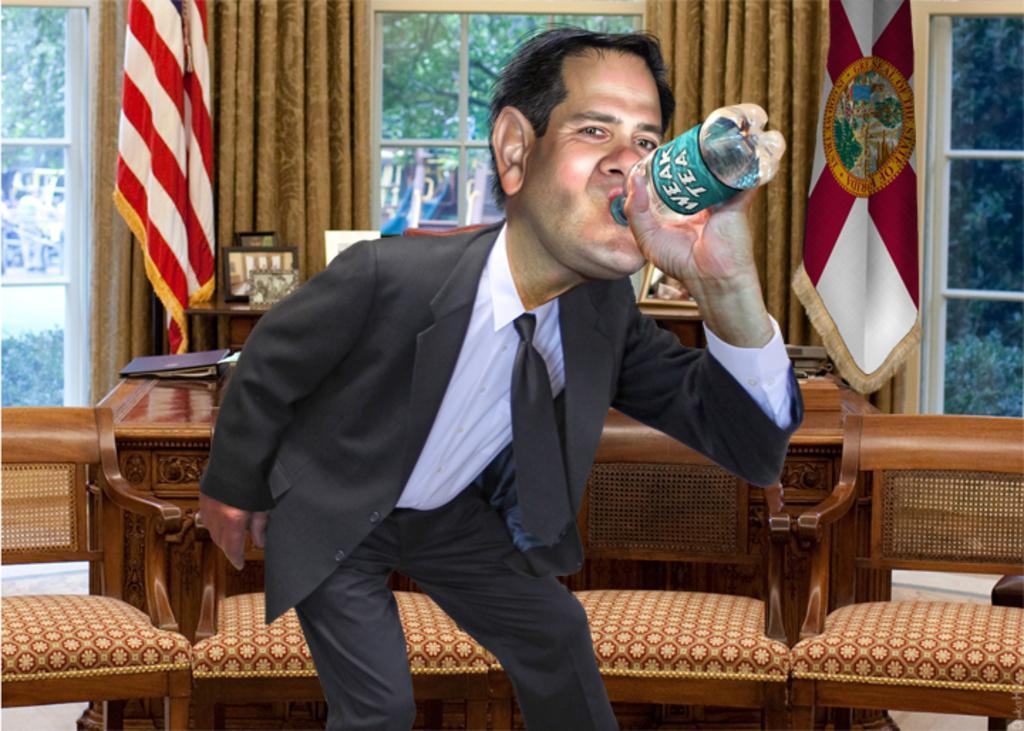Describe this image in one or two sentences. This picture was a person standing and holding a bottle. Backside to him there are few chairs and table. There is a file on it. Flags are there on both side of the person. At the background there are few trees. 